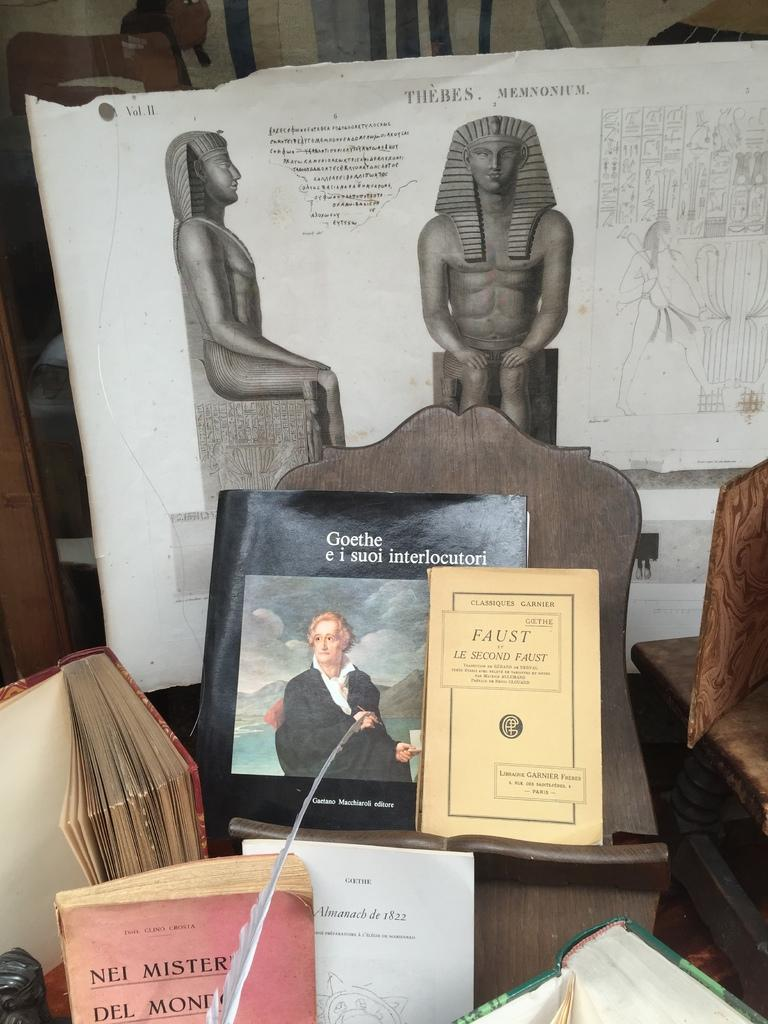<image>
Share a concise interpretation of the image provided. Booklet saying "Goethe" on display by a statue. 